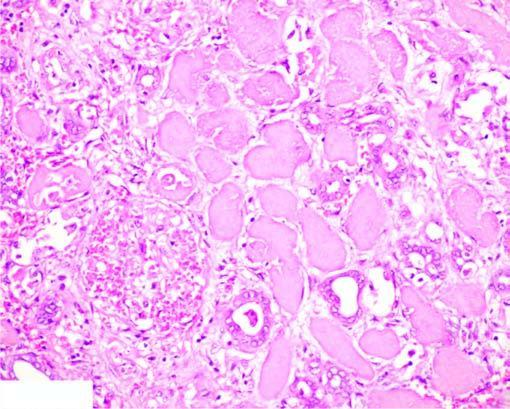do the nuclei show granular debris?
Answer the question using a single word or phrase. Yes 